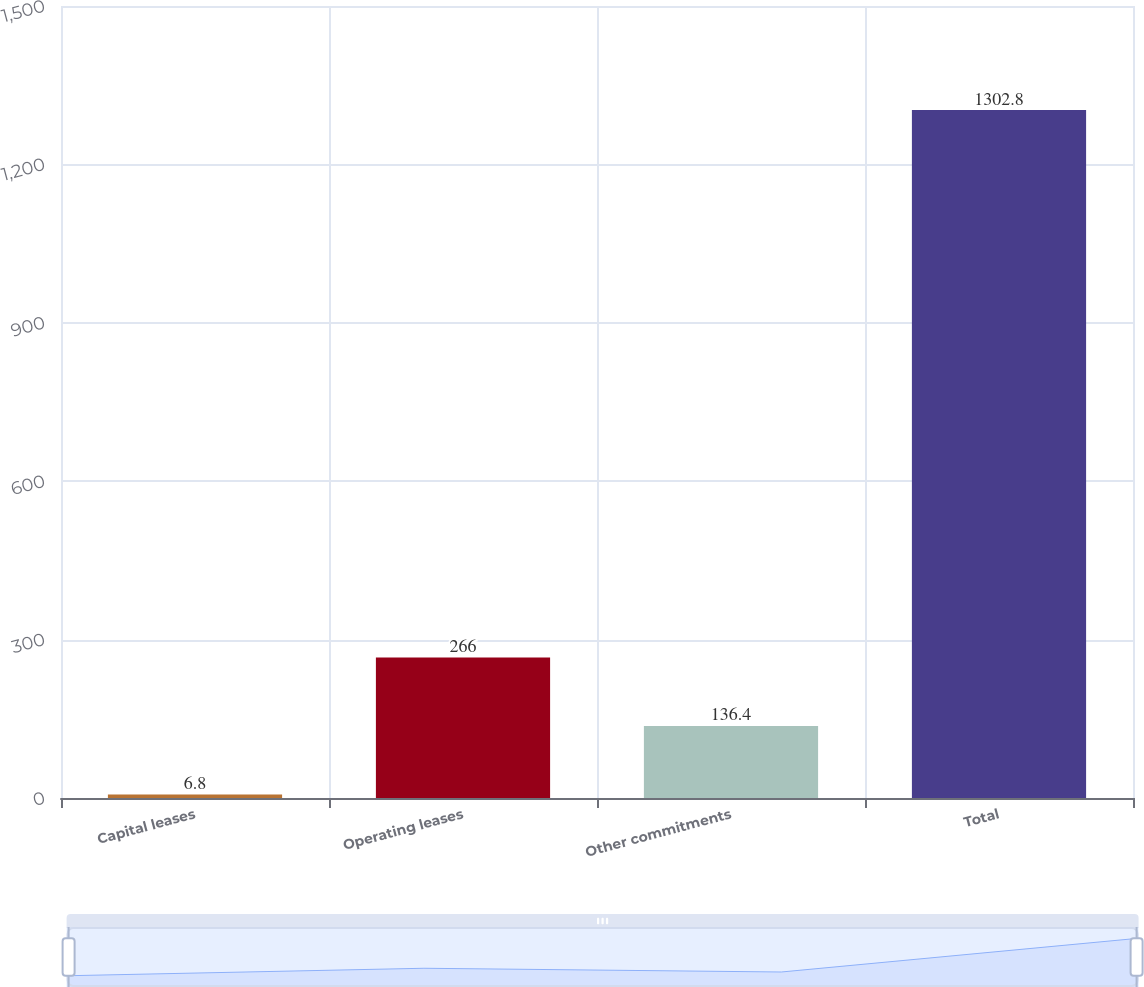<chart> <loc_0><loc_0><loc_500><loc_500><bar_chart><fcel>Capital leases<fcel>Operating leases<fcel>Other commitments<fcel>Total<nl><fcel>6.8<fcel>266<fcel>136.4<fcel>1302.8<nl></chart> 